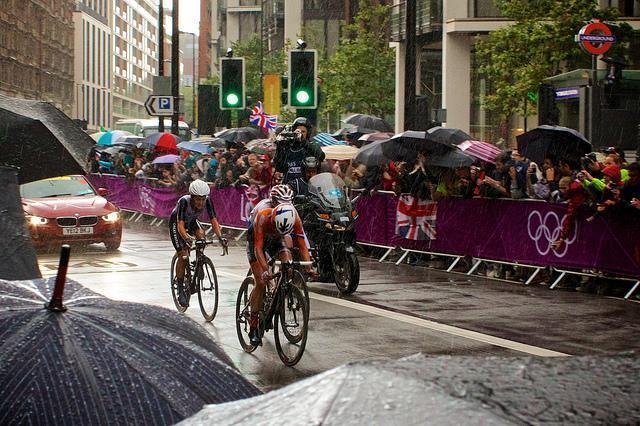How many bicycles can be seen?
Give a very brief answer. 2. How many umbrellas are there?
Give a very brief answer. 3. How many people are visible?
Give a very brief answer. 2. How many of the boats in the front have yellow poles?
Give a very brief answer. 0. 